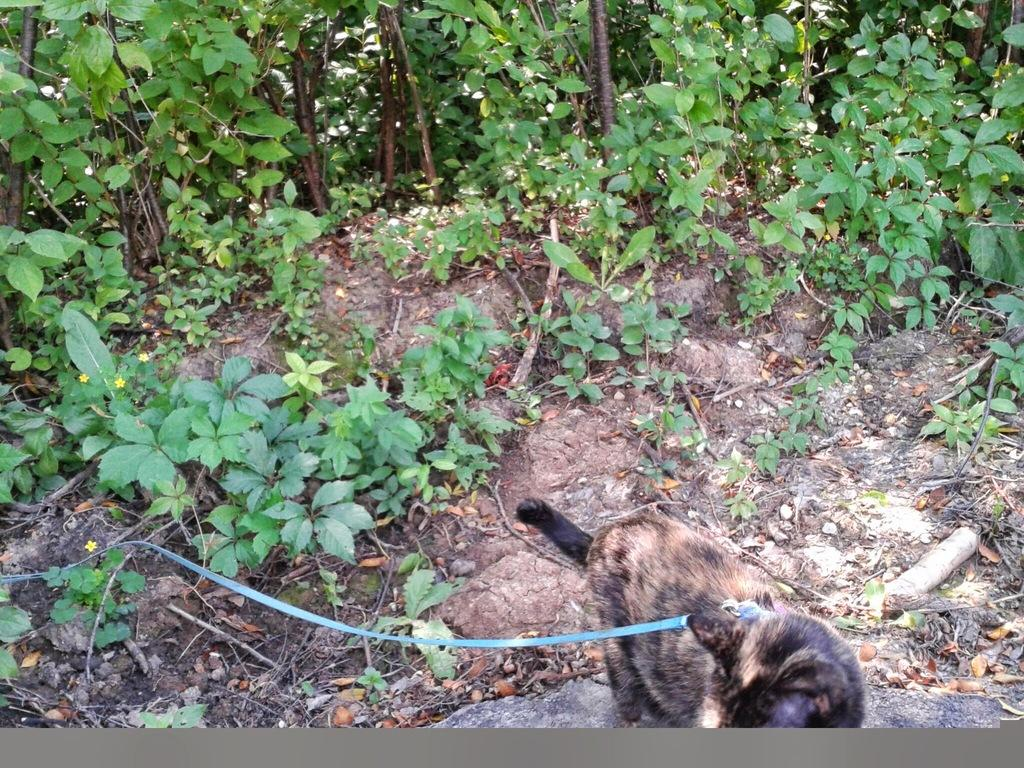What type of animal is at the bottom of the image? There is an animal present at the bottom of the image. What can be seen in the background of the image? There are plants visible in the background of the image. What type of bird can be seen attempting to fly in the image? There is no bird present in the image, nor is there any attempt to fly. What type of loaf is visible in the image? There is no loaf present in the image. 